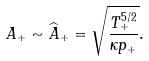Convert formula to latex. <formula><loc_0><loc_0><loc_500><loc_500>A _ { + } \sim \widehat { A } _ { + } = \sqrt { \frac { T _ { + } ^ { 5 / 2 } } { \kappa p _ { + } } } .</formula> 